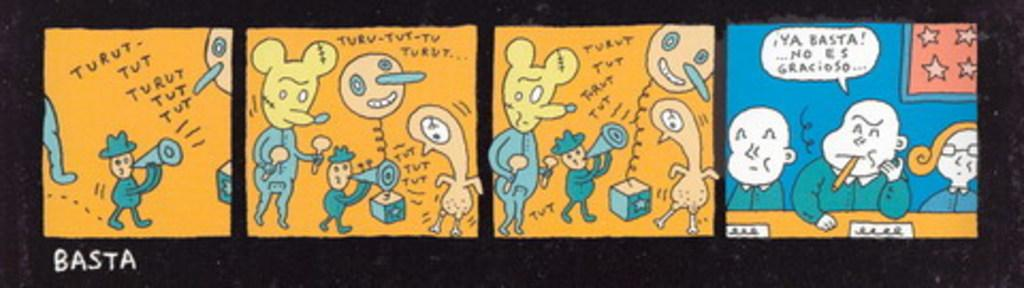<image>
Create a compact narrative representing the image presented. A four part comic strip written by Basta. 